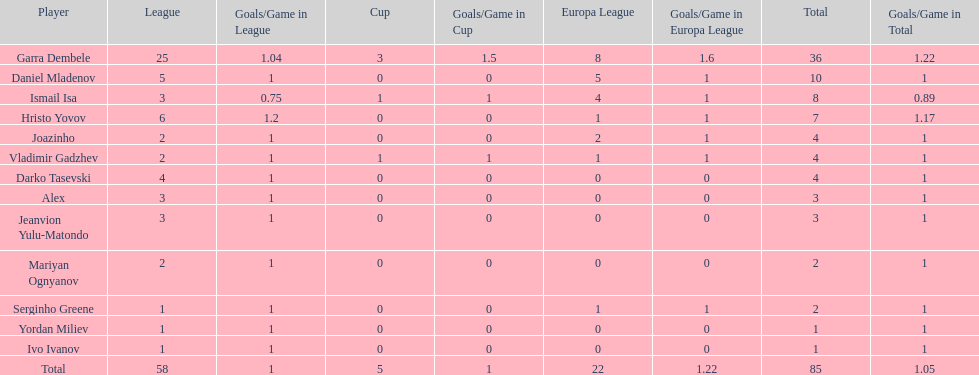Which player has the most goals to their name? Garra Dembele. Help me parse the entirety of this table. {'header': ['Player', 'League', 'Goals/Game in League', 'Cup', 'Goals/Game in Cup', 'Europa League', 'Goals/Game in Europa League', 'Total', 'Goals/Game in Total'], 'rows': [['Garra Dembele', '25', '1.04', '3', '1.5', '8', '1.6', '36', '1.22'], ['Daniel Mladenov', '5', '1', '0', '0', '5', '1', '10', '1'], ['Ismail Isa', '3', '0.75', '1', '1', '4', '1', '8', '0.89'], ['Hristo Yovov', '6', '1.2', '0', '0', '1', '1', '7', '1.17'], ['Joazinho', '2', '1', '0', '0', '2', '1', '4', '1'], ['Vladimir Gadzhev', '2', '1', '1', '1', '1', '1', '4', '1'], ['Darko Tasevski', '4', '1', '0', '0', '0', '0', '4', '1'], ['Alex', '3', '1', '0', '0', '0', '0', '3', '1'], ['Jeanvion Yulu-Matondo', '3', '1', '0', '0', '0', '0', '3', '1'], ['Mariyan Ognyanov', '2', '1', '0', '0', '0', '0', '2', '1'], ['Serginho Greene', '1', '1', '0', '0', '1', '1', '2', '1'], ['Yordan Miliev', '1', '1', '0', '0', '0', '0', '1', '1'], ['Ivo Ivanov', '1', '1', '0', '0', '0', '0', '1', '1'], ['Total', '58', '1', '5', '1', '22', '1.22', '85', '1.05']]} 